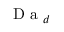Convert formula to latex. <formula><loc_0><loc_0><loc_500><loc_500>D a _ { d }</formula> 